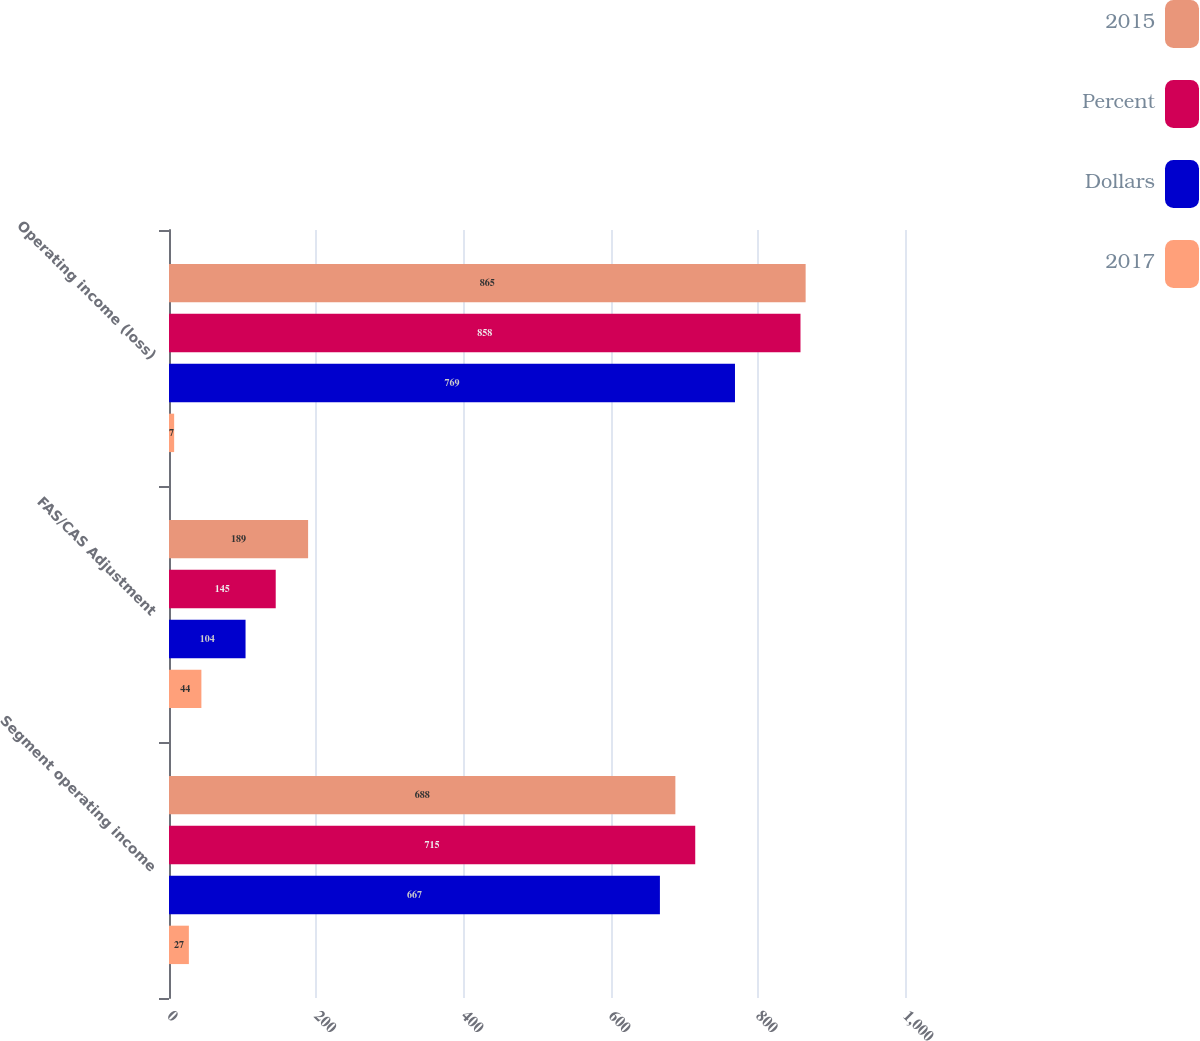Convert chart to OTSL. <chart><loc_0><loc_0><loc_500><loc_500><stacked_bar_chart><ecel><fcel>Segment operating income<fcel>FAS/CAS Adjustment<fcel>Operating income (loss)<nl><fcel>2015<fcel>688<fcel>189<fcel>865<nl><fcel>Percent<fcel>715<fcel>145<fcel>858<nl><fcel>Dollars<fcel>667<fcel>104<fcel>769<nl><fcel>2017<fcel>27<fcel>44<fcel>7<nl></chart> 